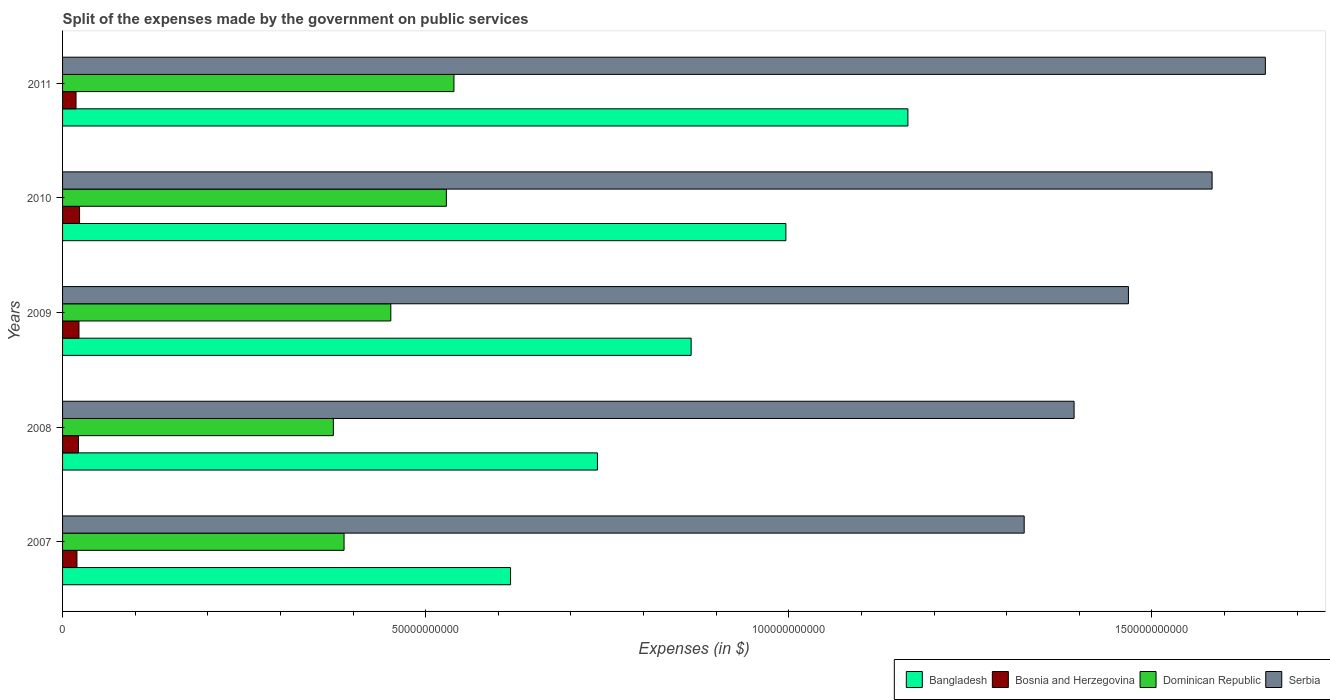How many different coloured bars are there?
Make the answer very short. 4. How many groups of bars are there?
Your response must be concise. 5. Are the number of bars on each tick of the Y-axis equal?
Your answer should be very brief. Yes. What is the label of the 3rd group of bars from the top?
Give a very brief answer. 2009. In how many cases, is the number of bars for a given year not equal to the number of legend labels?
Provide a short and direct response. 0. What is the expenses made by the government on public services in Bangladesh in 2009?
Your answer should be compact. 8.66e+1. Across all years, what is the maximum expenses made by the government on public services in Dominican Republic?
Your response must be concise. 5.39e+1. Across all years, what is the minimum expenses made by the government on public services in Dominican Republic?
Your answer should be compact. 3.73e+1. In which year was the expenses made by the government on public services in Dominican Republic maximum?
Your answer should be compact. 2011. What is the total expenses made by the government on public services in Serbia in the graph?
Provide a short and direct response. 7.42e+11. What is the difference between the expenses made by the government on public services in Bosnia and Herzegovina in 2008 and that in 2010?
Your answer should be compact. -1.49e+08. What is the difference between the expenses made by the government on public services in Dominican Republic in 2011 and the expenses made by the government on public services in Serbia in 2008?
Make the answer very short. -8.54e+1. What is the average expenses made by the government on public services in Serbia per year?
Ensure brevity in your answer.  1.48e+11. In the year 2007, what is the difference between the expenses made by the government on public services in Bangladesh and expenses made by the government on public services in Serbia?
Give a very brief answer. -7.07e+1. What is the ratio of the expenses made by the government on public services in Serbia in 2009 to that in 2011?
Provide a succinct answer. 0.89. What is the difference between the highest and the second highest expenses made by the government on public services in Bangladesh?
Ensure brevity in your answer.  1.68e+1. What is the difference between the highest and the lowest expenses made by the government on public services in Dominican Republic?
Offer a terse response. 1.66e+1. In how many years, is the expenses made by the government on public services in Serbia greater than the average expenses made by the government on public services in Serbia taken over all years?
Your response must be concise. 2. What does the 2nd bar from the top in 2010 represents?
Give a very brief answer. Dominican Republic. What does the 3rd bar from the bottom in 2008 represents?
Give a very brief answer. Dominican Republic. How many bars are there?
Provide a succinct answer. 20. Are all the bars in the graph horizontal?
Offer a very short reply. Yes. Where does the legend appear in the graph?
Ensure brevity in your answer.  Bottom right. How many legend labels are there?
Your answer should be compact. 4. What is the title of the graph?
Make the answer very short. Split of the expenses made by the government on public services. What is the label or title of the X-axis?
Your response must be concise. Expenses (in $). What is the Expenses (in $) of Bangladesh in 2007?
Provide a succinct answer. 6.17e+1. What is the Expenses (in $) in Bosnia and Herzegovina in 2007?
Ensure brevity in your answer.  1.98e+09. What is the Expenses (in $) of Dominican Republic in 2007?
Your answer should be very brief. 3.88e+1. What is the Expenses (in $) in Serbia in 2007?
Your answer should be very brief. 1.32e+11. What is the Expenses (in $) in Bangladesh in 2008?
Keep it short and to the point. 7.36e+1. What is the Expenses (in $) of Bosnia and Herzegovina in 2008?
Provide a succinct answer. 2.19e+09. What is the Expenses (in $) in Dominican Republic in 2008?
Your answer should be compact. 3.73e+1. What is the Expenses (in $) in Serbia in 2008?
Provide a short and direct response. 1.39e+11. What is the Expenses (in $) of Bangladesh in 2009?
Make the answer very short. 8.66e+1. What is the Expenses (in $) in Bosnia and Herzegovina in 2009?
Your answer should be very brief. 2.26e+09. What is the Expenses (in $) of Dominican Republic in 2009?
Ensure brevity in your answer.  4.52e+1. What is the Expenses (in $) of Serbia in 2009?
Offer a very short reply. 1.47e+11. What is the Expenses (in $) in Bangladesh in 2010?
Provide a succinct answer. 9.96e+1. What is the Expenses (in $) in Bosnia and Herzegovina in 2010?
Give a very brief answer. 2.34e+09. What is the Expenses (in $) in Dominican Republic in 2010?
Your answer should be very brief. 5.28e+1. What is the Expenses (in $) in Serbia in 2010?
Provide a short and direct response. 1.58e+11. What is the Expenses (in $) of Bangladesh in 2011?
Your answer should be compact. 1.16e+11. What is the Expenses (in $) of Bosnia and Herzegovina in 2011?
Keep it short and to the point. 1.86e+09. What is the Expenses (in $) in Dominican Republic in 2011?
Your answer should be compact. 5.39e+1. What is the Expenses (in $) in Serbia in 2011?
Provide a succinct answer. 1.66e+11. Across all years, what is the maximum Expenses (in $) of Bangladesh?
Ensure brevity in your answer.  1.16e+11. Across all years, what is the maximum Expenses (in $) in Bosnia and Herzegovina?
Provide a succinct answer. 2.34e+09. Across all years, what is the maximum Expenses (in $) in Dominican Republic?
Provide a short and direct response. 5.39e+1. Across all years, what is the maximum Expenses (in $) in Serbia?
Make the answer very short. 1.66e+11. Across all years, what is the minimum Expenses (in $) of Bangladesh?
Keep it short and to the point. 6.17e+1. Across all years, what is the minimum Expenses (in $) in Bosnia and Herzegovina?
Your answer should be compact. 1.86e+09. Across all years, what is the minimum Expenses (in $) in Dominican Republic?
Your answer should be compact. 3.73e+1. Across all years, what is the minimum Expenses (in $) of Serbia?
Your response must be concise. 1.32e+11. What is the total Expenses (in $) of Bangladesh in the graph?
Offer a terse response. 4.38e+11. What is the total Expenses (in $) in Bosnia and Herzegovina in the graph?
Your response must be concise. 1.06e+1. What is the total Expenses (in $) in Dominican Republic in the graph?
Your response must be concise. 2.28e+11. What is the total Expenses (in $) of Serbia in the graph?
Offer a terse response. 7.42e+11. What is the difference between the Expenses (in $) in Bangladesh in 2007 and that in 2008?
Your answer should be very brief. -1.20e+1. What is the difference between the Expenses (in $) of Bosnia and Herzegovina in 2007 and that in 2008?
Your answer should be very brief. -2.13e+08. What is the difference between the Expenses (in $) of Dominican Republic in 2007 and that in 2008?
Offer a terse response. 1.48e+09. What is the difference between the Expenses (in $) of Serbia in 2007 and that in 2008?
Your answer should be very brief. -6.87e+09. What is the difference between the Expenses (in $) of Bangladesh in 2007 and that in 2009?
Provide a succinct answer. -2.49e+1. What is the difference between the Expenses (in $) of Bosnia and Herzegovina in 2007 and that in 2009?
Provide a short and direct response. -2.80e+08. What is the difference between the Expenses (in $) of Dominican Republic in 2007 and that in 2009?
Your response must be concise. -6.44e+09. What is the difference between the Expenses (in $) of Serbia in 2007 and that in 2009?
Keep it short and to the point. -1.44e+1. What is the difference between the Expenses (in $) of Bangladesh in 2007 and that in 2010?
Ensure brevity in your answer.  -3.79e+1. What is the difference between the Expenses (in $) of Bosnia and Herzegovina in 2007 and that in 2010?
Provide a short and direct response. -3.61e+08. What is the difference between the Expenses (in $) in Dominican Republic in 2007 and that in 2010?
Your response must be concise. -1.41e+1. What is the difference between the Expenses (in $) in Serbia in 2007 and that in 2010?
Your answer should be compact. -2.59e+1. What is the difference between the Expenses (in $) in Bangladesh in 2007 and that in 2011?
Your response must be concise. -5.47e+1. What is the difference between the Expenses (in $) of Bosnia and Herzegovina in 2007 and that in 2011?
Ensure brevity in your answer.  1.23e+08. What is the difference between the Expenses (in $) of Dominican Republic in 2007 and that in 2011?
Keep it short and to the point. -1.51e+1. What is the difference between the Expenses (in $) of Serbia in 2007 and that in 2011?
Offer a very short reply. -3.32e+1. What is the difference between the Expenses (in $) in Bangladesh in 2008 and that in 2009?
Offer a very short reply. -1.29e+1. What is the difference between the Expenses (in $) of Bosnia and Herzegovina in 2008 and that in 2009?
Offer a very short reply. -6.71e+07. What is the difference between the Expenses (in $) of Dominican Republic in 2008 and that in 2009?
Ensure brevity in your answer.  -7.91e+09. What is the difference between the Expenses (in $) in Serbia in 2008 and that in 2009?
Provide a succinct answer. -7.48e+09. What is the difference between the Expenses (in $) in Bangladesh in 2008 and that in 2010?
Provide a short and direct response. -2.59e+1. What is the difference between the Expenses (in $) in Bosnia and Herzegovina in 2008 and that in 2010?
Make the answer very short. -1.49e+08. What is the difference between the Expenses (in $) of Dominican Republic in 2008 and that in 2010?
Ensure brevity in your answer.  -1.56e+1. What is the difference between the Expenses (in $) of Serbia in 2008 and that in 2010?
Make the answer very short. -1.90e+1. What is the difference between the Expenses (in $) in Bangladesh in 2008 and that in 2011?
Ensure brevity in your answer.  -4.27e+1. What is the difference between the Expenses (in $) of Bosnia and Herzegovina in 2008 and that in 2011?
Make the answer very short. 3.36e+08. What is the difference between the Expenses (in $) in Dominican Republic in 2008 and that in 2011?
Keep it short and to the point. -1.66e+1. What is the difference between the Expenses (in $) of Serbia in 2008 and that in 2011?
Ensure brevity in your answer.  -2.63e+1. What is the difference between the Expenses (in $) in Bangladesh in 2009 and that in 2010?
Provide a succinct answer. -1.30e+1. What is the difference between the Expenses (in $) in Bosnia and Herzegovina in 2009 and that in 2010?
Your answer should be compact. -8.16e+07. What is the difference between the Expenses (in $) in Dominican Republic in 2009 and that in 2010?
Offer a terse response. -7.65e+09. What is the difference between the Expenses (in $) of Serbia in 2009 and that in 2010?
Your answer should be very brief. -1.15e+1. What is the difference between the Expenses (in $) in Bangladesh in 2009 and that in 2011?
Offer a very short reply. -2.98e+1. What is the difference between the Expenses (in $) of Bosnia and Herzegovina in 2009 and that in 2011?
Offer a terse response. 4.03e+08. What is the difference between the Expenses (in $) of Dominican Republic in 2009 and that in 2011?
Keep it short and to the point. -8.70e+09. What is the difference between the Expenses (in $) in Serbia in 2009 and that in 2011?
Give a very brief answer. -1.89e+1. What is the difference between the Expenses (in $) of Bangladesh in 2010 and that in 2011?
Ensure brevity in your answer.  -1.68e+1. What is the difference between the Expenses (in $) of Bosnia and Herzegovina in 2010 and that in 2011?
Provide a succinct answer. 4.85e+08. What is the difference between the Expenses (in $) of Dominican Republic in 2010 and that in 2011?
Your answer should be very brief. -1.04e+09. What is the difference between the Expenses (in $) in Serbia in 2010 and that in 2011?
Your answer should be very brief. -7.33e+09. What is the difference between the Expenses (in $) of Bangladesh in 2007 and the Expenses (in $) of Bosnia and Herzegovina in 2008?
Keep it short and to the point. 5.95e+1. What is the difference between the Expenses (in $) in Bangladesh in 2007 and the Expenses (in $) in Dominican Republic in 2008?
Provide a succinct answer. 2.44e+1. What is the difference between the Expenses (in $) of Bangladesh in 2007 and the Expenses (in $) of Serbia in 2008?
Ensure brevity in your answer.  -7.76e+1. What is the difference between the Expenses (in $) in Bosnia and Herzegovina in 2007 and the Expenses (in $) in Dominican Republic in 2008?
Keep it short and to the point. -3.53e+1. What is the difference between the Expenses (in $) in Bosnia and Herzegovina in 2007 and the Expenses (in $) in Serbia in 2008?
Your response must be concise. -1.37e+11. What is the difference between the Expenses (in $) of Dominican Republic in 2007 and the Expenses (in $) of Serbia in 2008?
Make the answer very short. -1.01e+11. What is the difference between the Expenses (in $) in Bangladesh in 2007 and the Expenses (in $) in Bosnia and Herzegovina in 2009?
Offer a terse response. 5.94e+1. What is the difference between the Expenses (in $) of Bangladesh in 2007 and the Expenses (in $) of Dominican Republic in 2009?
Ensure brevity in your answer.  1.65e+1. What is the difference between the Expenses (in $) in Bangladesh in 2007 and the Expenses (in $) in Serbia in 2009?
Keep it short and to the point. -8.51e+1. What is the difference between the Expenses (in $) in Bosnia and Herzegovina in 2007 and the Expenses (in $) in Dominican Republic in 2009?
Provide a short and direct response. -4.32e+1. What is the difference between the Expenses (in $) in Bosnia and Herzegovina in 2007 and the Expenses (in $) in Serbia in 2009?
Your response must be concise. -1.45e+11. What is the difference between the Expenses (in $) in Dominican Republic in 2007 and the Expenses (in $) in Serbia in 2009?
Your response must be concise. -1.08e+11. What is the difference between the Expenses (in $) of Bangladesh in 2007 and the Expenses (in $) of Bosnia and Herzegovina in 2010?
Make the answer very short. 5.93e+1. What is the difference between the Expenses (in $) in Bangladesh in 2007 and the Expenses (in $) in Dominican Republic in 2010?
Your answer should be very brief. 8.84e+09. What is the difference between the Expenses (in $) in Bangladesh in 2007 and the Expenses (in $) in Serbia in 2010?
Offer a very short reply. -9.66e+1. What is the difference between the Expenses (in $) of Bosnia and Herzegovina in 2007 and the Expenses (in $) of Dominican Republic in 2010?
Make the answer very short. -5.09e+1. What is the difference between the Expenses (in $) of Bosnia and Herzegovina in 2007 and the Expenses (in $) of Serbia in 2010?
Your response must be concise. -1.56e+11. What is the difference between the Expenses (in $) in Dominican Republic in 2007 and the Expenses (in $) in Serbia in 2010?
Offer a very short reply. -1.20e+11. What is the difference between the Expenses (in $) of Bangladesh in 2007 and the Expenses (in $) of Bosnia and Herzegovina in 2011?
Offer a very short reply. 5.98e+1. What is the difference between the Expenses (in $) in Bangladesh in 2007 and the Expenses (in $) in Dominican Republic in 2011?
Keep it short and to the point. 7.79e+09. What is the difference between the Expenses (in $) of Bangladesh in 2007 and the Expenses (in $) of Serbia in 2011?
Keep it short and to the point. -1.04e+11. What is the difference between the Expenses (in $) in Bosnia and Herzegovina in 2007 and the Expenses (in $) in Dominican Republic in 2011?
Offer a terse response. -5.19e+1. What is the difference between the Expenses (in $) of Bosnia and Herzegovina in 2007 and the Expenses (in $) of Serbia in 2011?
Make the answer very short. -1.64e+11. What is the difference between the Expenses (in $) of Dominican Republic in 2007 and the Expenses (in $) of Serbia in 2011?
Your response must be concise. -1.27e+11. What is the difference between the Expenses (in $) of Bangladesh in 2008 and the Expenses (in $) of Bosnia and Herzegovina in 2009?
Your answer should be compact. 7.14e+1. What is the difference between the Expenses (in $) of Bangladesh in 2008 and the Expenses (in $) of Dominican Republic in 2009?
Give a very brief answer. 2.85e+1. What is the difference between the Expenses (in $) in Bangladesh in 2008 and the Expenses (in $) in Serbia in 2009?
Provide a succinct answer. -7.31e+1. What is the difference between the Expenses (in $) in Bosnia and Herzegovina in 2008 and the Expenses (in $) in Dominican Republic in 2009?
Keep it short and to the point. -4.30e+1. What is the difference between the Expenses (in $) of Bosnia and Herzegovina in 2008 and the Expenses (in $) of Serbia in 2009?
Keep it short and to the point. -1.45e+11. What is the difference between the Expenses (in $) of Dominican Republic in 2008 and the Expenses (in $) of Serbia in 2009?
Your answer should be very brief. -1.09e+11. What is the difference between the Expenses (in $) in Bangladesh in 2008 and the Expenses (in $) in Bosnia and Herzegovina in 2010?
Give a very brief answer. 7.13e+1. What is the difference between the Expenses (in $) of Bangladesh in 2008 and the Expenses (in $) of Dominican Republic in 2010?
Offer a terse response. 2.08e+1. What is the difference between the Expenses (in $) of Bangladesh in 2008 and the Expenses (in $) of Serbia in 2010?
Provide a short and direct response. -8.46e+1. What is the difference between the Expenses (in $) of Bosnia and Herzegovina in 2008 and the Expenses (in $) of Dominican Republic in 2010?
Provide a short and direct response. -5.07e+1. What is the difference between the Expenses (in $) in Bosnia and Herzegovina in 2008 and the Expenses (in $) in Serbia in 2010?
Keep it short and to the point. -1.56e+11. What is the difference between the Expenses (in $) in Dominican Republic in 2008 and the Expenses (in $) in Serbia in 2010?
Offer a very short reply. -1.21e+11. What is the difference between the Expenses (in $) of Bangladesh in 2008 and the Expenses (in $) of Bosnia and Herzegovina in 2011?
Your answer should be very brief. 7.18e+1. What is the difference between the Expenses (in $) in Bangladesh in 2008 and the Expenses (in $) in Dominican Republic in 2011?
Give a very brief answer. 1.98e+1. What is the difference between the Expenses (in $) of Bangladesh in 2008 and the Expenses (in $) of Serbia in 2011?
Offer a terse response. -9.20e+1. What is the difference between the Expenses (in $) in Bosnia and Herzegovina in 2008 and the Expenses (in $) in Dominican Republic in 2011?
Make the answer very short. -5.17e+1. What is the difference between the Expenses (in $) in Bosnia and Herzegovina in 2008 and the Expenses (in $) in Serbia in 2011?
Your response must be concise. -1.63e+11. What is the difference between the Expenses (in $) of Dominican Republic in 2008 and the Expenses (in $) of Serbia in 2011?
Keep it short and to the point. -1.28e+11. What is the difference between the Expenses (in $) in Bangladesh in 2009 and the Expenses (in $) in Bosnia and Herzegovina in 2010?
Give a very brief answer. 8.42e+1. What is the difference between the Expenses (in $) in Bangladesh in 2009 and the Expenses (in $) in Dominican Republic in 2010?
Keep it short and to the point. 3.37e+1. What is the difference between the Expenses (in $) of Bangladesh in 2009 and the Expenses (in $) of Serbia in 2010?
Make the answer very short. -7.17e+1. What is the difference between the Expenses (in $) of Bosnia and Herzegovina in 2009 and the Expenses (in $) of Dominican Republic in 2010?
Give a very brief answer. -5.06e+1. What is the difference between the Expenses (in $) of Bosnia and Herzegovina in 2009 and the Expenses (in $) of Serbia in 2010?
Make the answer very short. -1.56e+11. What is the difference between the Expenses (in $) in Dominican Republic in 2009 and the Expenses (in $) in Serbia in 2010?
Your answer should be very brief. -1.13e+11. What is the difference between the Expenses (in $) in Bangladesh in 2009 and the Expenses (in $) in Bosnia and Herzegovina in 2011?
Keep it short and to the point. 8.47e+1. What is the difference between the Expenses (in $) of Bangladesh in 2009 and the Expenses (in $) of Dominican Republic in 2011?
Offer a terse response. 3.27e+1. What is the difference between the Expenses (in $) of Bangladesh in 2009 and the Expenses (in $) of Serbia in 2011?
Offer a very short reply. -7.91e+1. What is the difference between the Expenses (in $) of Bosnia and Herzegovina in 2009 and the Expenses (in $) of Dominican Republic in 2011?
Ensure brevity in your answer.  -5.16e+1. What is the difference between the Expenses (in $) in Bosnia and Herzegovina in 2009 and the Expenses (in $) in Serbia in 2011?
Your answer should be very brief. -1.63e+11. What is the difference between the Expenses (in $) of Dominican Republic in 2009 and the Expenses (in $) of Serbia in 2011?
Ensure brevity in your answer.  -1.20e+11. What is the difference between the Expenses (in $) of Bangladesh in 2010 and the Expenses (in $) of Bosnia and Herzegovina in 2011?
Offer a terse response. 9.77e+1. What is the difference between the Expenses (in $) in Bangladesh in 2010 and the Expenses (in $) in Dominican Republic in 2011?
Give a very brief answer. 4.57e+1. What is the difference between the Expenses (in $) of Bangladesh in 2010 and the Expenses (in $) of Serbia in 2011?
Offer a terse response. -6.60e+1. What is the difference between the Expenses (in $) of Bosnia and Herzegovina in 2010 and the Expenses (in $) of Dominican Republic in 2011?
Your answer should be compact. -5.16e+1. What is the difference between the Expenses (in $) of Bosnia and Herzegovina in 2010 and the Expenses (in $) of Serbia in 2011?
Make the answer very short. -1.63e+11. What is the difference between the Expenses (in $) of Dominican Republic in 2010 and the Expenses (in $) of Serbia in 2011?
Make the answer very short. -1.13e+11. What is the average Expenses (in $) of Bangladesh per year?
Provide a short and direct response. 8.76e+1. What is the average Expenses (in $) in Bosnia and Herzegovina per year?
Give a very brief answer. 2.12e+09. What is the average Expenses (in $) in Dominican Republic per year?
Provide a succinct answer. 4.56e+1. What is the average Expenses (in $) of Serbia per year?
Your response must be concise. 1.48e+11. In the year 2007, what is the difference between the Expenses (in $) in Bangladesh and Expenses (in $) in Bosnia and Herzegovina?
Offer a very short reply. 5.97e+1. In the year 2007, what is the difference between the Expenses (in $) of Bangladesh and Expenses (in $) of Dominican Republic?
Your answer should be very brief. 2.29e+1. In the year 2007, what is the difference between the Expenses (in $) of Bangladesh and Expenses (in $) of Serbia?
Your answer should be compact. -7.07e+1. In the year 2007, what is the difference between the Expenses (in $) in Bosnia and Herzegovina and Expenses (in $) in Dominican Republic?
Give a very brief answer. -3.68e+1. In the year 2007, what is the difference between the Expenses (in $) in Bosnia and Herzegovina and Expenses (in $) in Serbia?
Provide a short and direct response. -1.30e+11. In the year 2007, what is the difference between the Expenses (in $) in Dominican Republic and Expenses (in $) in Serbia?
Provide a succinct answer. -9.36e+1. In the year 2008, what is the difference between the Expenses (in $) of Bangladesh and Expenses (in $) of Bosnia and Herzegovina?
Make the answer very short. 7.15e+1. In the year 2008, what is the difference between the Expenses (in $) of Bangladesh and Expenses (in $) of Dominican Republic?
Offer a terse response. 3.64e+1. In the year 2008, what is the difference between the Expenses (in $) of Bangladesh and Expenses (in $) of Serbia?
Your answer should be very brief. -6.56e+1. In the year 2008, what is the difference between the Expenses (in $) of Bosnia and Herzegovina and Expenses (in $) of Dominican Republic?
Make the answer very short. -3.51e+1. In the year 2008, what is the difference between the Expenses (in $) in Bosnia and Herzegovina and Expenses (in $) in Serbia?
Give a very brief answer. -1.37e+11. In the year 2008, what is the difference between the Expenses (in $) in Dominican Republic and Expenses (in $) in Serbia?
Your answer should be very brief. -1.02e+11. In the year 2009, what is the difference between the Expenses (in $) in Bangladesh and Expenses (in $) in Bosnia and Herzegovina?
Your answer should be very brief. 8.43e+1. In the year 2009, what is the difference between the Expenses (in $) in Bangladesh and Expenses (in $) in Dominican Republic?
Your answer should be compact. 4.14e+1. In the year 2009, what is the difference between the Expenses (in $) of Bangladesh and Expenses (in $) of Serbia?
Offer a terse response. -6.02e+1. In the year 2009, what is the difference between the Expenses (in $) of Bosnia and Herzegovina and Expenses (in $) of Dominican Republic?
Provide a short and direct response. -4.29e+1. In the year 2009, what is the difference between the Expenses (in $) of Bosnia and Herzegovina and Expenses (in $) of Serbia?
Offer a very short reply. -1.45e+11. In the year 2009, what is the difference between the Expenses (in $) in Dominican Republic and Expenses (in $) in Serbia?
Provide a succinct answer. -1.02e+11. In the year 2010, what is the difference between the Expenses (in $) in Bangladesh and Expenses (in $) in Bosnia and Herzegovina?
Your answer should be compact. 9.73e+1. In the year 2010, what is the difference between the Expenses (in $) of Bangladesh and Expenses (in $) of Dominican Republic?
Provide a short and direct response. 4.67e+1. In the year 2010, what is the difference between the Expenses (in $) in Bangladesh and Expenses (in $) in Serbia?
Provide a short and direct response. -5.87e+1. In the year 2010, what is the difference between the Expenses (in $) in Bosnia and Herzegovina and Expenses (in $) in Dominican Republic?
Provide a short and direct response. -5.05e+1. In the year 2010, what is the difference between the Expenses (in $) in Bosnia and Herzegovina and Expenses (in $) in Serbia?
Provide a succinct answer. -1.56e+11. In the year 2010, what is the difference between the Expenses (in $) of Dominican Republic and Expenses (in $) of Serbia?
Your answer should be very brief. -1.05e+11. In the year 2011, what is the difference between the Expenses (in $) of Bangladesh and Expenses (in $) of Bosnia and Herzegovina?
Ensure brevity in your answer.  1.15e+11. In the year 2011, what is the difference between the Expenses (in $) in Bangladesh and Expenses (in $) in Dominican Republic?
Provide a short and direct response. 6.25e+1. In the year 2011, what is the difference between the Expenses (in $) in Bangladesh and Expenses (in $) in Serbia?
Your answer should be compact. -4.92e+1. In the year 2011, what is the difference between the Expenses (in $) in Bosnia and Herzegovina and Expenses (in $) in Dominican Republic?
Offer a very short reply. -5.20e+1. In the year 2011, what is the difference between the Expenses (in $) of Bosnia and Herzegovina and Expenses (in $) of Serbia?
Offer a very short reply. -1.64e+11. In the year 2011, what is the difference between the Expenses (in $) of Dominican Republic and Expenses (in $) of Serbia?
Provide a short and direct response. -1.12e+11. What is the ratio of the Expenses (in $) of Bangladesh in 2007 to that in 2008?
Provide a succinct answer. 0.84. What is the ratio of the Expenses (in $) in Bosnia and Herzegovina in 2007 to that in 2008?
Offer a terse response. 0.9. What is the ratio of the Expenses (in $) in Dominican Republic in 2007 to that in 2008?
Provide a succinct answer. 1.04. What is the ratio of the Expenses (in $) of Serbia in 2007 to that in 2008?
Your response must be concise. 0.95. What is the ratio of the Expenses (in $) in Bangladesh in 2007 to that in 2009?
Your answer should be compact. 0.71. What is the ratio of the Expenses (in $) in Bosnia and Herzegovina in 2007 to that in 2009?
Keep it short and to the point. 0.88. What is the ratio of the Expenses (in $) in Dominican Republic in 2007 to that in 2009?
Offer a terse response. 0.86. What is the ratio of the Expenses (in $) in Serbia in 2007 to that in 2009?
Your response must be concise. 0.9. What is the ratio of the Expenses (in $) in Bangladesh in 2007 to that in 2010?
Offer a very short reply. 0.62. What is the ratio of the Expenses (in $) in Bosnia and Herzegovina in 2007 to that in 2010?
Ensure brevity in your answer.  0.85. What is the ratio of the Expenses (in $) in Dominican Republic in 2007 to that in 2010?
Provide a short and direct response. 0.73. What is the ratio of the Expenses (in $) in Serbia in 2007 to that in 2010?
Offer a very short reply. 0.84. What is the ratio of the Expenses (in $) in Bangladesh in 2007 to that in 2011?
Your answer should be very brief. 0.53. What is the ratio of the Expenses (in $) of Bosnia and Herzegovina in 2007 to that in 2011?
Ensure brevity in your answer.  1.07. What is the ratio of the Expenses (in $) in Dominican Republic in 2007 to that in 2011?
Provide a succinct answer. 0.72. What is the ratio of the Expenses (in $) in Serbia in 2007 to that in 2011?
Provide a succinct answer. 0.8. What is the ratio of the Expenses (in $) of Bangladesh in 2008 to that in 2009?
Your answer should be compact. 0.85. What is the ratio of the Expenses (in $) of Bosnia and Herzegovina in 2008 to that in 2009?
Provide a succinct answer. 0.97. What is the ratio of the Expenses (in $) of Dominican Republic in 2008 to that in 2009?
Keep it short and to the point. 0.82. What is the ratio of the Expenses (in $) in Serbia in 2008 to that in 2009?
Give a very brief answer. 0.95. What is the ratio of the Expenses (in $) in Bangladesh in 2008 to that in 2010?
Your answer should be compact. 0.74. What is the ratio of the Expenses (in $) of Bosnia and Herzegovina in 2008 to that in 2010?
Your answer should be compact. 0.94. What is the ratio of the Expenses (in $) in Dominican Republic in 2008 to that in 2010?
Provide a short and direct response. 0.71. What is the ratio of the Expenses (in $) of Serbia in 2008 to that in 2010?
Ensure brevity in your answer.  0.88. What is the ratio of the Expenses (in $) of Bangladesh in 2008 to that in 2011?
Ensure brevity in your answer.  0.63. What is the ratio of the Expenses (in $) of Bosnia and Herzegovina in 2008 to that in 2011?
Provide a short and direct response. 1.18. What is the ratio of the Expenses (in $) of Dominican Republic in 2008 to that in 2011?
Ensure brevity in your answer.  0.69. What is the ratio of the Expenses (in $) in Serbia in 2008 to that in 2011?
Offer a terse response. 0.84. What is the ratio of the Expenses (in $) in Bangladesh in 2009 to that in 2010?
Your response must be concise. 0.87. What is the ratio of the Expenses (in $) in Bosnia and Herzegovina in 2009 to that in 2010?
Ensure brevity in your answer.  0.97. What is the ratio of the Expenses (in $) in Dominican Republic in 2009 to that in 2010?
Provide a succinct answer. 0.86. What is the ratio of the Expenses (in $) in Serbia in 2009 to that in 2010?
Your answer should be very brief. 0.93. What is the ratio of the Expenses (in $) of Bangladesh in 2009 to that in 2011?
Your answer should be compact. 0.74. What is the ratio of the Expenses (in $) of Bosnia and Herzegovina in 2009 to that in 2011?
Keep it short and to the point. 1.22. What is the ratio of the Expenses (in $) of Dominican Republic in 2009 to that in 2011?
Offer a very short reply. 0.84. What is the ratio of the Expenses (in $) of Serbia in 2009 to that in 2011?
Keep it short and to the point. 0.89. What is the ratio of the Expenses (in $) in Bangladesh in 2010 to that in 2011?
Offer a very short reply. 0.86. What is the ratio of the Expenses (in $) of Bosnia and Herzegovina in 2010 to that in 2011?
Ensure brevity in your answer.  1.26. What is the ratio of the Expenses (in $) in Dominican Republic in 2010 to that in 2011?
Your answer should be compact. 0.98. What is the ratio of the Expenses (in $) in Serbia in 2010 to that in 2011?
Ensure brevity in your answer.  0.96. What is the difference between the highest and the second highest Expenses (in $) in Bangladesh?
Give a very brief answer. 1.68e+1. What is the difference between the highest and the second highest Expenses (in $) in Bosnia and Herzegovina?
Provide a short and direct response. 8.16e+07. What is the difference between the highest and the second highest Expenses (in $) in Dominican Republic?
Provide a succinct answer. 1.04e+09. What is the difference between the highest and the second highest Expenses (in $) of Serbia?
Offer a very short reply. 7.33e+09. What is the difference between the highest and the lowest Expenses (in $) in Bangladesh?
Your answer should be very brief. 5.47e+1. What is the difference between the highest and the lowest Expenses (in $) of Bosnia and Herzegovina?
Keep it short and to the point. 4.85e+08. What is the difference between the highest and the lowest Expenses (in $) in Dominican Republic?
Your answer should be very brief. 1.66e+1. What is the difference between the highest and the lowest Expenses (in $) in Serbia?
Provide a succinct answer. 3.32e+1. 